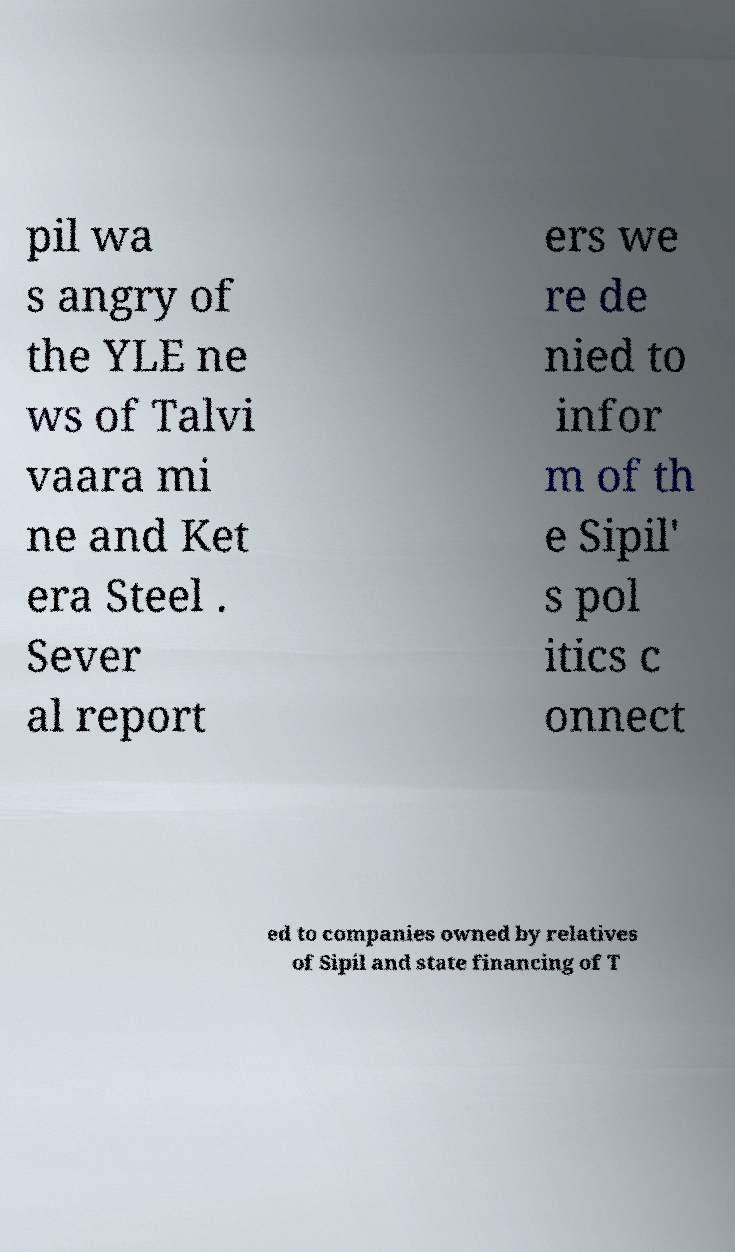Could you assist in decoding the text presented in this image and type it out clearly? pil wa s angry of the YLE ne ws of Talvi vaara mi ne and Ket era Steel . Sever al report ers we re de nied to infor m of th e Sipil' s pol itics c onnect ed to companies owned by relatives of Sipil and state financing of T 